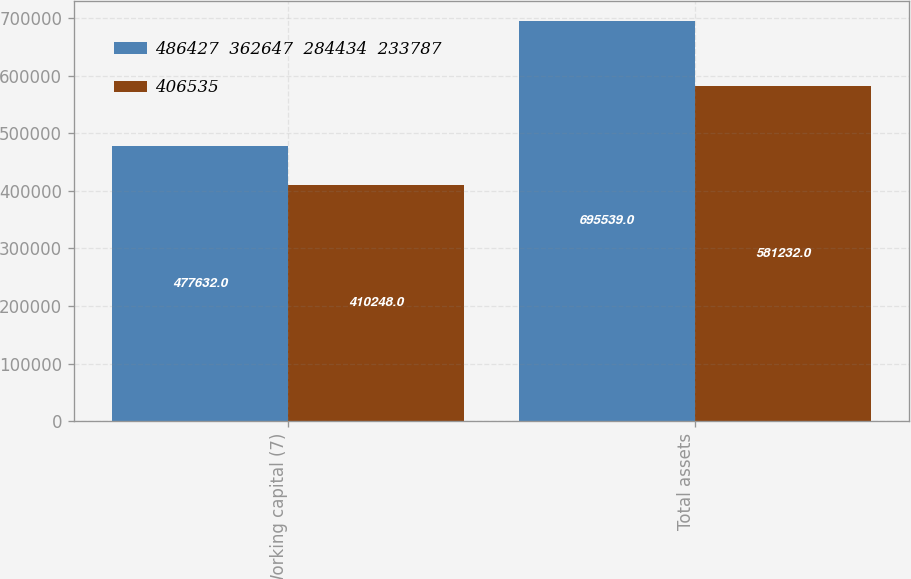Convert chart. <chart><loc_0><loc_0><loc_500><loc_500><stacked_bar_chart><ecel><fcel>Working capital (7)<fcel>Total assets<nl><fcel>486427  362647  284434  233787<fcel>477632<fcel>695539<nl><fcel>406535<fcel>410248<fcel>581232<nl></chart> 